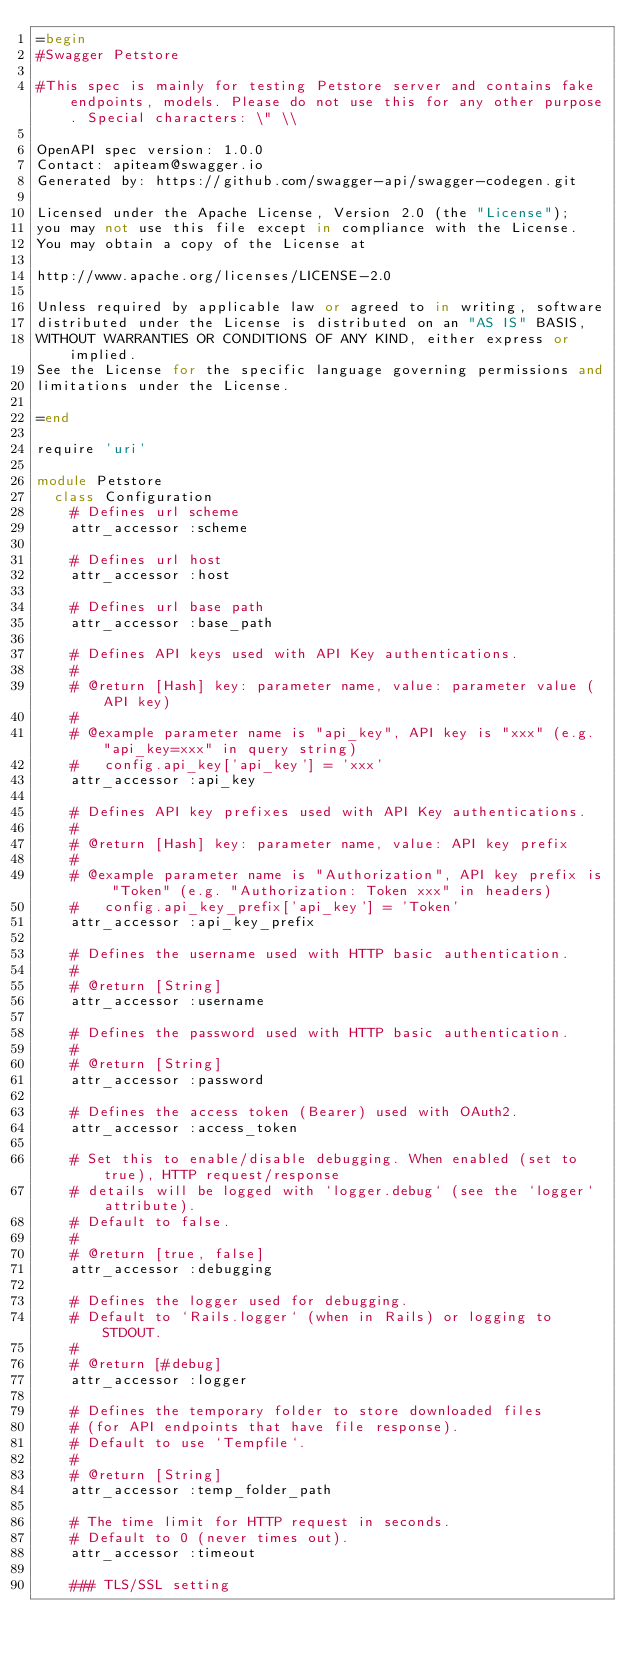Convert code to text. <code><loc_0><loc_0><loc_500><loc_500><_Ruby_>=begin
#Swagger Petstore

#This spec is mainly for testing Petstore server and contains fake endpoints, models. Please do not use this for any other purpose. Special characters: \" \\

OpenAPI spec version: 1.0.0
Contact: apiteam@swagger.io
Generated by: https://github.com/swagger-api/swagger-codegen.git

Licensed under the Apache License, Version 2.0 (the "License");
you may not use this file except in compliance with the License.
You may obtain a copy of the License at

http://www.apache.org/licenses/LICENSE-2.0

Unless required by applicable law or agreed to in writing, software
distributed under the License is distributed on an "AS IS" BASIS,
WITHOUT WARRANTIES OR CONDITIONS OF ANY KIND, either express or implied.
See the License for the specific language governing permissions and
limitations under the License.

=end

require 'uri'

module Petstore
  class Configuration
    # Defines url scheme
    attr_accessor :scheme

    # Defines url host
    attr_accessor :host

    # Defines url base path
    attr_accessor :base_path

    # Defines API keys used with API Key authentications.
    #
    # @return [Hash] key: parameter name, value: parameter value (API key)
    #
    # @example parameter name is "api_key", API key is "xxx" (e.g. "api_key=xxx" in query string)
    #   config.api_key['api_key'] = 'xxx'
    attr_accessor :api_key

    # Defines API key prefixes used with API Key authentications.
    #
    # @return [Hash] key: parameter name, value: API key prefix
    #
    # @example parameter name is "Authorization", API key prefix is "Token" (e.g. "Authorization: Token xxx" in headers)
    #   config.api_key_prefix['api_key'] = 'Token'
    attr_accessor :api_key_prefix

    # Defines the username used with HTTP basic authentication.
    #
    # @return [String]
    attr_accessor :username

    # Defines the password used with HTTP basic authentication.
    #
    # @return [String]
    attr_accessor :password

    # Defines the access token (Bearer) used with OAuth2.
    attr_accessor :access_token

    # Set this to enable/disable debugging. When enabled (set to true), HTTP request/response
    # details will be logged with `logger.debug` (see the `logger` attribute).
    # Default to false.
    #
    # @return [true, false]
    attr_accessor :debugging

    # Defines the logger used for debugging.
    # Default to `Rails.logger` (when in Rails) or logging to STDOUT.
    #
    # @return [#debug]
    attr_accessor :logger

    # Defines the temporary folder to store downloaded files
    # (for API endpoints that have file response).
    # Default to use `Tempfile`.
    #
    # @return [String]
    attr_accessor :temp_folder_path

    # The time limit for HTTP request in seconds.
    # Default to 0 (never times out).
    attr_accessor :timeout

    ### TLS/SSL setting</code> 